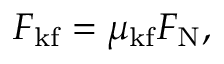Convert formula to latex. <formula><loc_0><loc_0><loc_500><loc_500>F _ { k f } = \mu _ { k f } F _ { N } ,</formula> 